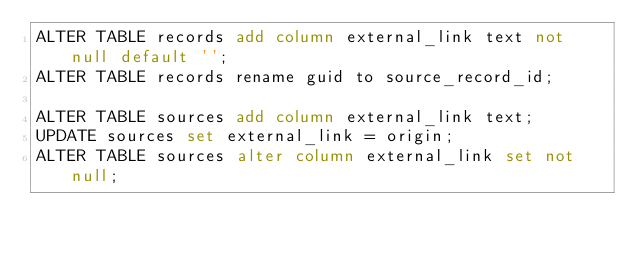<code> <loc_0><loc_0><loc_500><loc_500><_SQL_>ALTER TABLE records add column external_link text not null default '';
ALTER TABLE records rename guid to source_record_id;

ALTER TABLE sources add column external_link text;
UPDATE sources set external_link = origin;
ALTER TABLE sources alter column external_link set not null;
</code> 